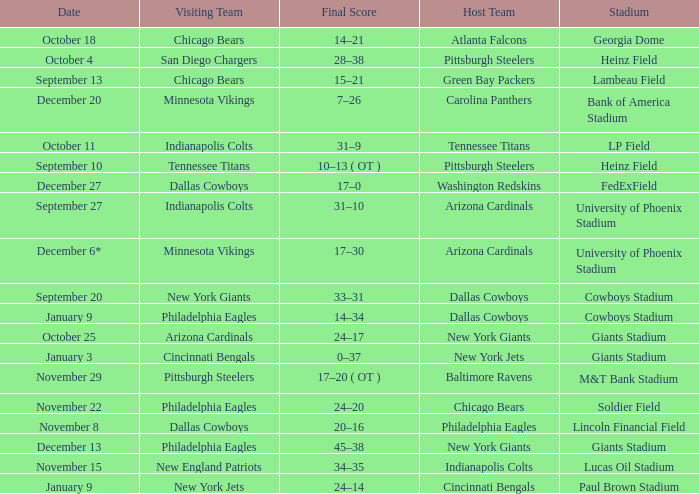Can you provide the date of the pittsburgh steelers game? November 29. 